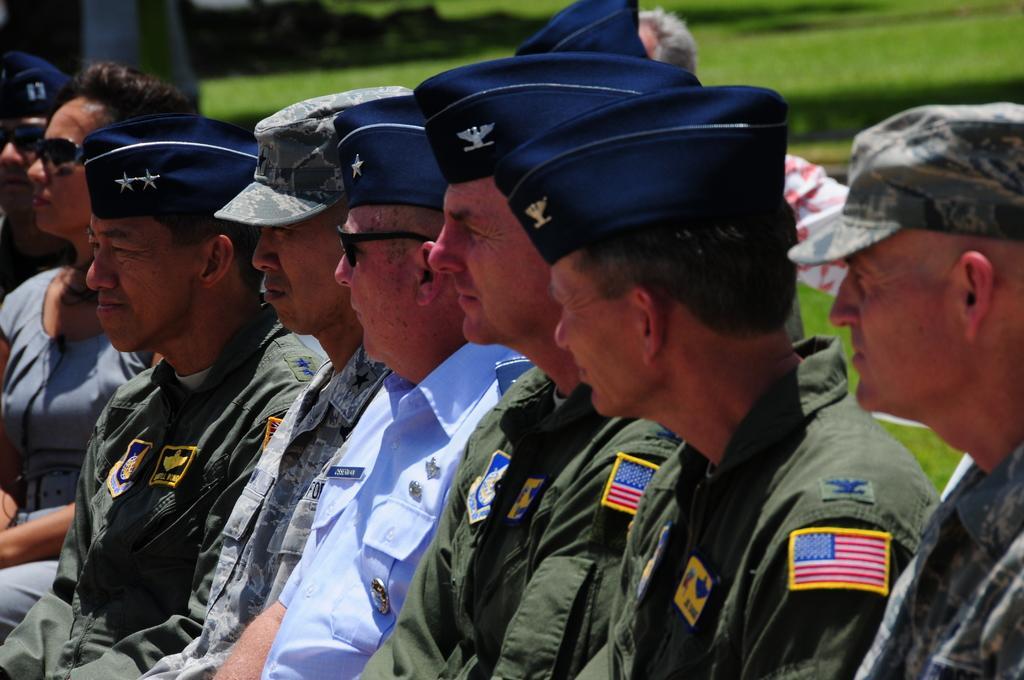How would you summarize this image in a sentence or two? In this image there are so many people sitting in row wearing uniform, behind them there is grass. 